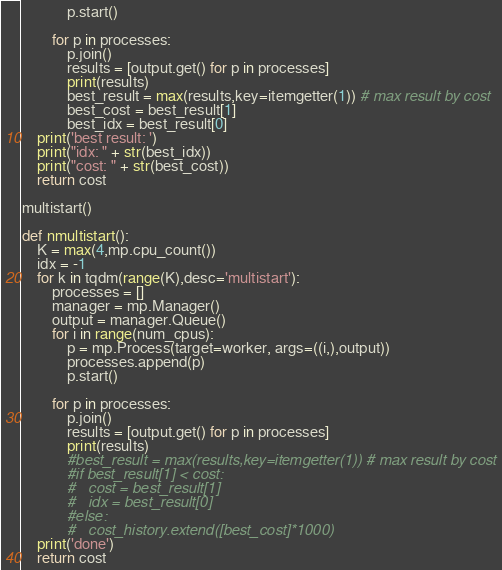<code> <loc_0><loc_0><loc_500><loc_500><_Python_>            p.start()

        for p in processes:
            p.join()
            results = [output.get() for p in processes]
            print(results)
            best_result = max(results,key=itemgetter(1)) # max result by cost
            best_cost = best_result[1]
            best_idx = best_result[0]
    print('best result: ')
    print("idx: " + str(best_idx))
    print("cost: " + str(best_cost))
    return cost

multistart()

def nmultistart():
    K = max(4,mp.cpu_count())
    idx = -1
    for k in tqdm(range(K),desc='multistart'):
        processes = []
        manager = mp.Manager()
        output = manager.Queue()
        for i in range(num_cpus):
            p = mp.Process(target=worker, args=((i,),output))
            processes.append(p)
            p.start()

        for p in processes:
            p.join()
            results = [output.get() for p in processes]
            print(results)
            #best_result = max(results,key=itemgetter(1)) # max result by cost
            #if best_result[1] < cost:
            #	cost = best_result[1]
            #	idx = best_result[0]
            #else:
            #	cost_history.extend([best_cost]*1000)
    print('done')
    return cost
</code> 